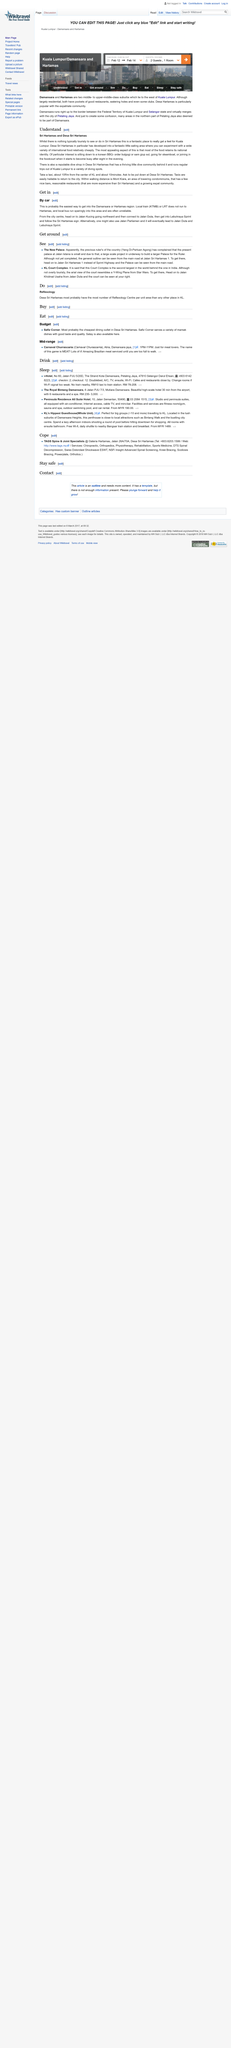Point out several critical features in this image. The reputable dive shop is located in Desa Sri Hartamas. The most attractive characteristic of the international food in Desa Sri Hartamas is that it maintains its original cultural identity in its cuisine. The foodcourt begins to experience a high volume of customers at around eight o'clock in the evening. 